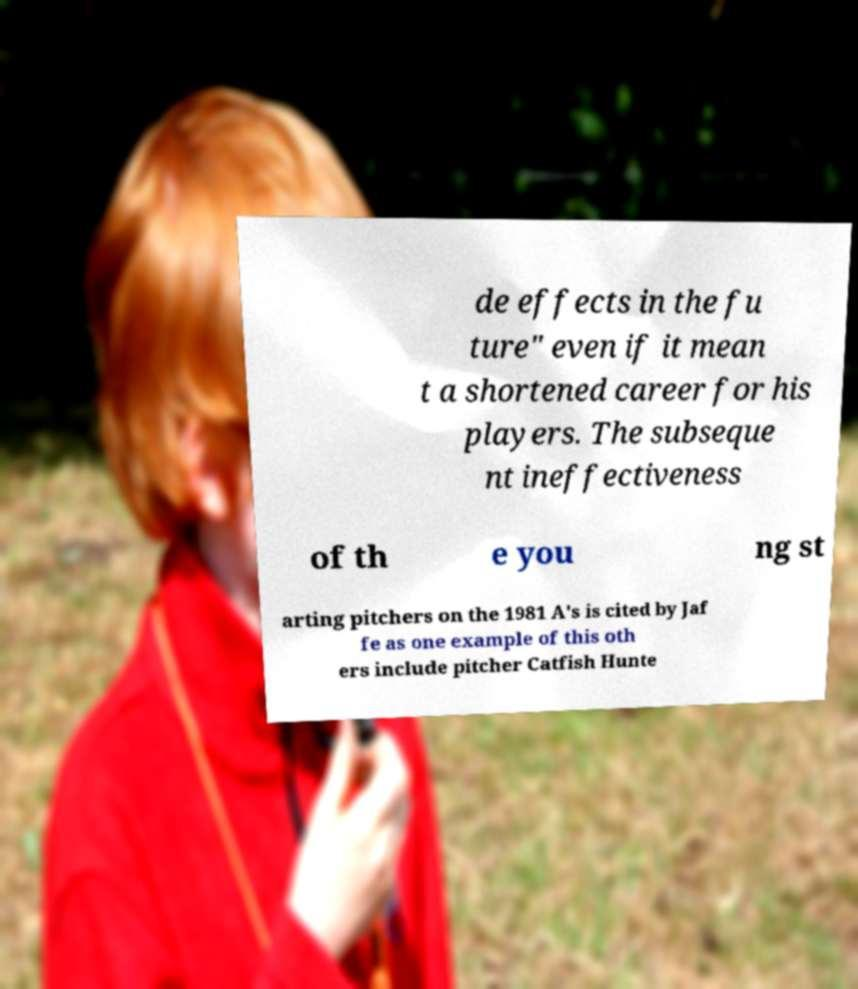Could you assist in decoding the text presented in this image and type it out clearly? de effects in the fu ture" even if it mean t a shortened career for his players. The subseque nt ineffectiveness of th e you ng st arting pitchers on the 1981 A's is cited by Jaf fe as one example of this oth ers include pitcher Catfish Hunte 